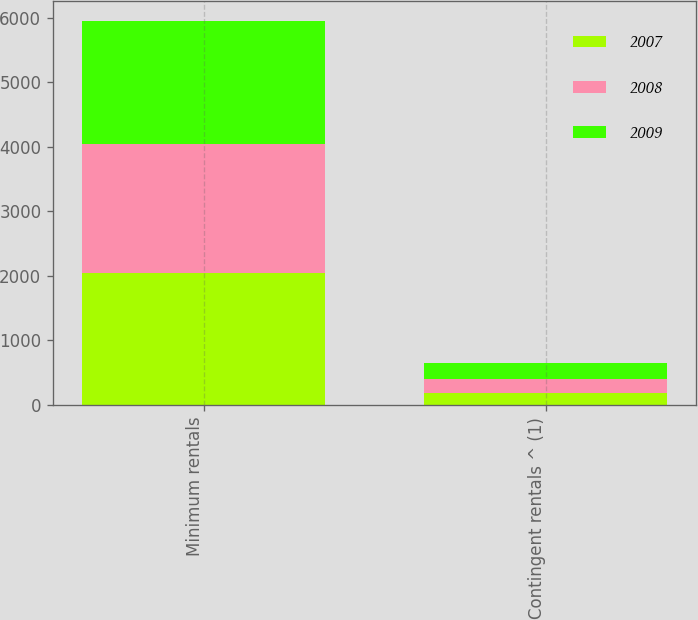<chart> <loc_0><loc_0><loc_500><loc_500><stacked_bar_chart><ecel><fcel>Minimum rentals<fcel>Contingent rentals ^ (1)<nl><fcel>2007<fcel>2047<fcel>181<nl><fcel>2008<fcel>1990<fcel>228<nl><fcel>2009<fcel>1916<fcel>241<nl></chart> 